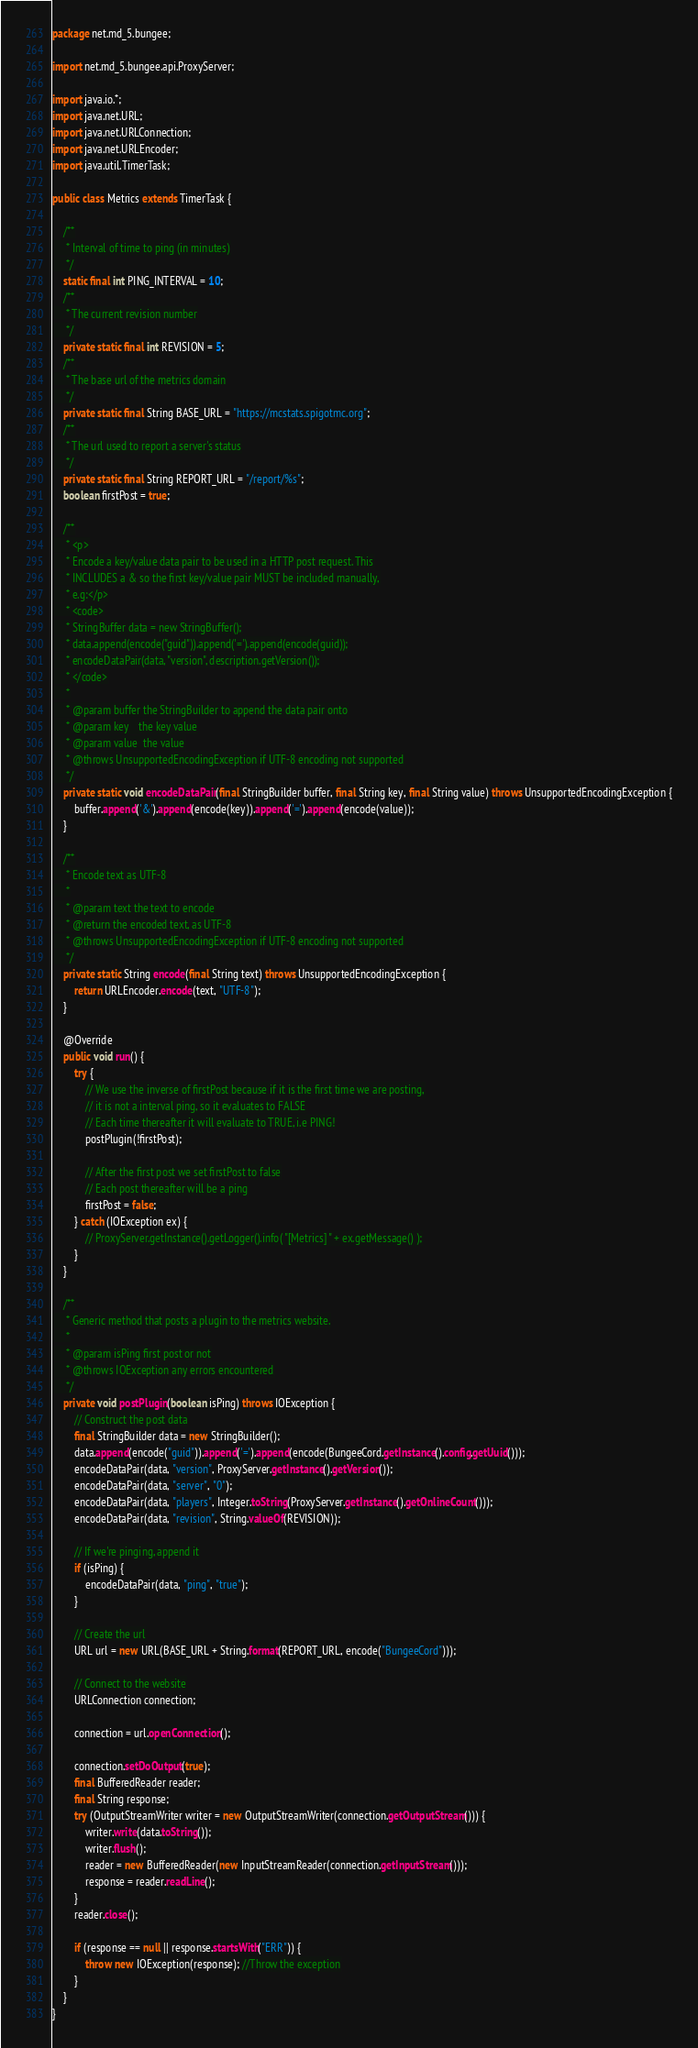Convert code to text. <code><loc_0><loc_0><loc_500><loc_500><_Java_>package net.md_5.bungee;

import net.md_5.bungee.api.ProxyServer;

import java.io.*;
import java.net.URL;
import java.net.URLConnection;
import java.net.URLEncoder;
import java.util.TimerTask;

public class Metrics extends TimerTask {

    /**
     * Interval of time to ping (in minutes)
     */
    static final int PING_INTERVAL = 10;
    /**
     * The current revision number
     */
    private static final int REVISION = 5;
    /**
     * The base url of the metrics domain
     */
    private static final String BASE_URL = "https://mcstats.spigotmc.org";
    /**
     * The url used to report a server's status
     */
    private static final String REPORT_URL = "/report/%s";
    boolean firstPost = true;

    /**
     * <p>
     * Encode a key/value data pair to be used in a HTTP post request. This
     * INCLUDES a & so the first key/value pair MUST be included manually,
     * e.g:</p>
     * <code>
     * StringBuffer data = new StringBuffer();
     * data.append(encode("guid")).append('=').append(encode(guid));
     * encodeDataPair(data, "version", description.getVersion());
     * </code>
     *
     * @param buffer the StringBuilder to append the data pair onto
     * @param key    the key value
     * @param value  the value
     * @throws UnsupportedEncodingException if UTF-8 encoding not supported
     */
    private static void encodeDataPair(final StringBuilder buffer, final String key, final String value) throws UnsupportedEncodingException {
        buffer.append('&').append(encode(key)).append('=').append(encode(value));
    }

    /**
     * Encode text as UTF-8
     *
     * @param text the text to encode
     * @return the encoded text, as UTF-8
     * @throws UnsupportedEncodingException if UTF-8 encoding not supported
     */
    private static String encode(final String text) throws UnsupportedEncodingException {
        return URLEncoder.encode(text, "UTF-8");
    }

    @Override
    public void run() {
        try {
            // We use the inverse of firstPost because if it is the first time we are posting,
            // it is not a interval ping, so it evaluates to FALSE
            // Each time thereafter it will evaluate to TRUE, i.e PING!
            postPlugin(!firstPost);

            // After the first post we set firstPost to false
            // Each post thereafter will be a ping
            firstPost = false;
        } catch (IOException ex) {
            // ProxyServer.getInstance().getLogger().info( "[Metrics] " + ex.getMessage() );
        }
    }

    /**
     * Generic method that posts a plugin to the metrics website.
     *
     * @param isPing first post or not
     * @throws IOException any errors encountered
     */
    private void postPlugin(boolean isPing) throws IOException {
        // Construct the post data
        final StringBuilder data = new StringBuilder();
        data.append(encode("guid")).append('=').append(encode(BungeeCord.getInstance().config.getUuid()));
        encodeDataPair(data, "version", ProxyServer.getInstance().getVersion());
        encodeDataPair(data, "server", "0");
        encodeDataPair(data, "players", Integer.toString(ProxyServer.getInstance().getOnlineCount()));
        encodeDataPair(data, "revision", String.valueOf(REVISION));

        // If we're pinging, append it
        if (isPing) {
            encodeDataPair(data, "ping", "true");
        }

        // Create the url
        URL url = new URL(BASE_URL + String.format(REPORT_URL, encode("BungeeCord")));

        // Connect to the website
        URLConnection connection;

        connection = url.openConnection();

        connection.setDoOutput(true);
        final BufferedReader reader;
        final String response;
        try (OutputStreamWriter writer = new OutputStreamWriter(connection.getOutputStream())) {
            writer.write(data.toString());
            writer.flush();
            reader = new BufferedReader(new InputStreamReader(connection.getInputStream()));
            response = reader.readLine();
        }
        reader.close();

        if (response == null || response.startsWith("ERR")) {
            throw new IOException(response); //Throw the exception
        }
    }
}
</code> 